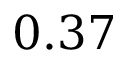Convert formula to latex. <formula><loc_0><loc_0><loc_500><loc_500>0 . 3 7</formula> 